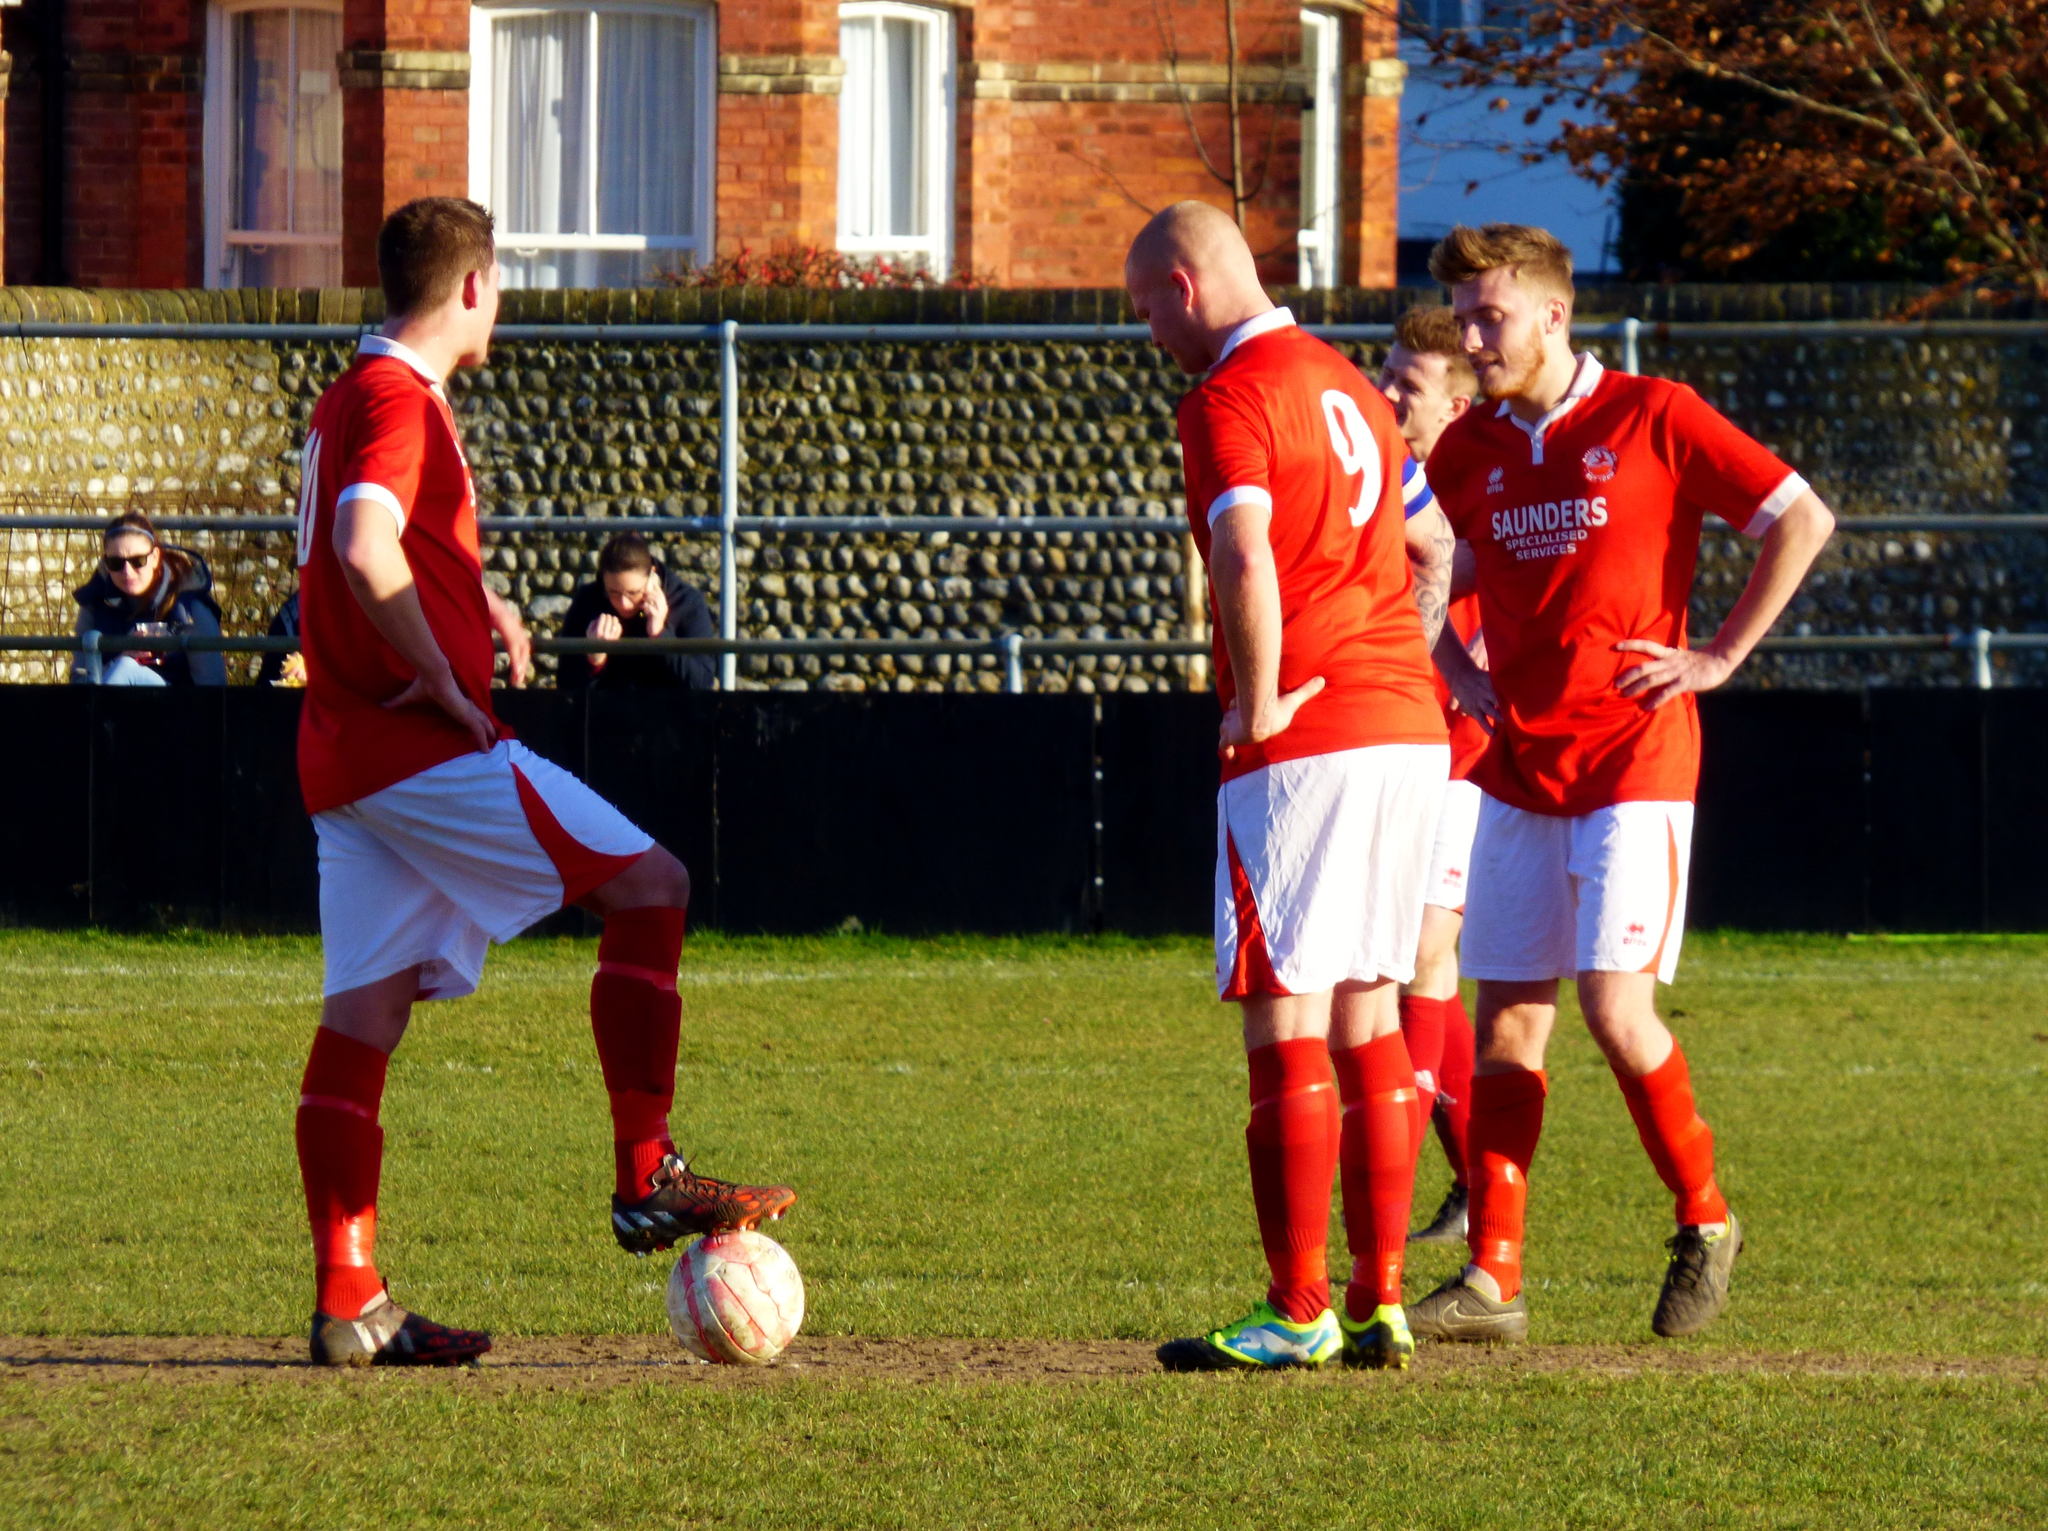<image>
Present a compact description of the photo's key features. Three soccer players are standing on the field including number 9. 